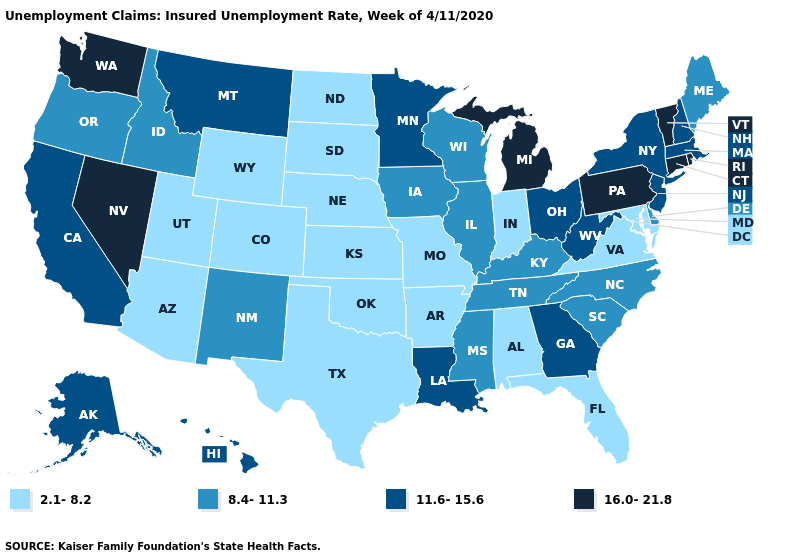What is the highest value in states that border Arkansas?
Concise answer only. 11.6-15.6. Name the states that have a value in the range 2.1-8.2?
Be succinct. Alabama, Arizona, Arkansas, Colorado, Florida, Indiana, Kansas, Maryland, Missouri, Nebraska, North Dakota, Oklahoma, South Dakota, Texas, Utah, Virginia, Wyoming. Which states have the lowest value in the USA?
Quick response, please. Alabama, Arizona, Arkansas, Colorado, Florida, Indiana, Kansas, Maryland, Missouri, Nebraska, North Dakota, Oklahoma, South Dakota, Texas, Utah, Virginia, Wyoming. Does Arizona have a lower value than Alabama?
Write a very short answer. No. What is the value of Tennessee?
Quick response, please. 8.4-11.3. What is the lowest value in the Northeast?
Concise answer only. 8.4-11.3. Which states have the lowest value in the MidWest?
Write a very short answer. Indiana, Kansas, Missouri, Nebraska, North Dakota, South Dakota. Does Washington have the highest value in the USA?
Be succinct. Yes. What is the lowest value in the South?
Keep it brief. 2.1-8.2. What is the value of Montana?
Concise answer only. 11.6-15.6. Name the states that have a value in the range 16.0-21.8?
Be succinct. Connecticut, Michigan, Nevada, Pennsylvania, Rhode Island, Vermont, Washington. Does the first symbol in the legend represent the smallest category?
Be succinct. Yes. Which states hav the highest value in the Northeast?
Quick response, please. Connecticut, Pennsylvania, Rhode Island, Vermont. Among the states that border Illinois , does Kentucky have the highest value?
Keep it brief. Yes. Name the states that have a value in the range 16.0-21.8?
Concise answer only. Connecticut, Michigan, Nevada, Pennsylvania, Rhode Island, Vermont, Washington. 